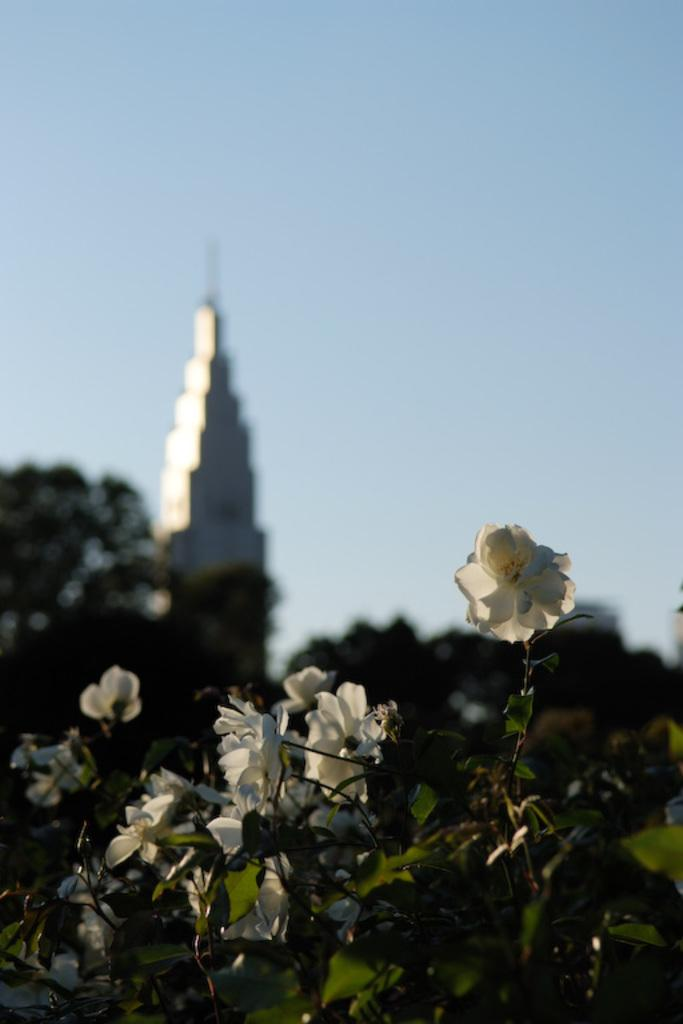What type of vegetation can be seen in the image? There are plants, flowers, and trees in the image. What structure is present in the image? There is a tower in the image. What is visible in the background of the image? The sky is visible in the background of the image. What type of cactus can be seen in the image? There is no cactus present in the image. What flavor of jam is being spread on the tower in the image? There is no jam or spreading activity depicted in the image. 